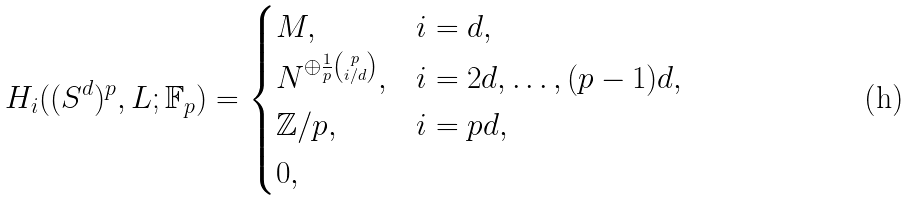Convert formula to latex. <formula><loc_0><loc_0><loc_500><loc_500>H _ { i } ( ( S ^ { d } ) ^ { p } , L ; \mathbb { F } _ { p } ) = \begin{cases} M , & i = d , \\ N ^ { \oplus \frac { 1 } { p } { p \choose i / d } } , & i = 2 d , \dots , ( p - 1 ) d , \\ \mathbb { Z } / p , & i = p d , \\ 0 , & \end{cases}</formula> 